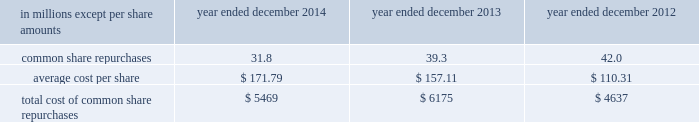Notes to consolidated financial statements guarantees of subsidiaries .
Group inc .
Fully and unconditionally guarantees the securities issued by gs finance corp. , a wholly-owned finance subsidiary of the group inc .
Has guaranteed the payment obligations of goldman , sachs & co .
( gs&co. ) , gs bank usa and goldman sachs execution & clearing , l.p .
( gsec ) , subject to certain exceptions .
In november 2008 , the firm contributed subsidiaries into gs bank usa , and group inc .
Agreed to guarantee the reimbursement of certain losses , including credit-related losses , relating to assets held by the contributed entities .
In connection with this guarantee , group inc .
Also agreed to pledge to gs bank usa certain collateral , including interests in subsidiaries and other illiquid assets .
In addition , group inc .
Guarantees many of the obligations of its other consolidated subsidiaries on a transaction-by- transaction basis , as negotiated with counterparties .
Group inc .
Is unable to develop an estimate of the maximum payout under its subsidiary guarantees ; however , because these guaranteed obligations are also obligations of consolidated subsidiaries , group inc . 2019s liabilities as guarantor are not separately disclosed .
Note 19 .
Shareholders 2019 equity common equity dividends declared per common share were $ 2.25 in 2014 , $ 2.05 in 2013 and $ 1.77 in 2012 .
On january 15 , 2015 , group inc .
Declared a dividend of $ 0.60 per common share to be paid on march 30 , 2015 to common shareholders of record on march 2 , 2015 .
The firm 2019s share repurchase program is intended to help maintain the appropriate level of common equity .
The share repurchase program is effected primarily through regular open-market purchases ( which may include repurchase plans designed to comply with rule 10b5-1 ) , the amounts and timing of which are determined primarily by the firm 2019s current and projected capital position , but which may also be influenced by general market conditions and the prevailing price and trading volumes of the firm 2019s common stock .
Prior to repurchasing common stock , the firm must receive confirmation that the federal reserve board does not object to such capital actions .
The table below presents the amount of common stock repurchased by the firm under the share repurchase program during 2014 , 2013 and 2012. .
Total cost of common share repurchases $ 5469 $ 6175 $ 4637 pursuant to the terms of certain share-based compensation plans , employees may remit shares to the firm or the firm may cancel restricted stock units ( rsus ) or stock options to satisfy minimum statutory employee tax withholding requirements and the exercise price of stock options .
Under these plans , during 2014 , 2013 and 2012 , employees remitted 174489 shares , 161211 shares and 33477 shares with a total value of $ 31 million , $ 25 million and $ 3 million , and the firm cancelled 5.8 million , 4.0 million and 12.7 million of rsus with a total value of $ 974 million , $ 599 million and $ 1.44 billion .
Under these plans , the firm also cancelled 15.6 million stock options with a total value of $ 2.65 billion during 2014 .
170 goldman sachs 2014 annual report .
What were total common equity dividends declared per common share for 2014 and 2013? 
Computations: (2.25 + 2.05)
Answer: 4.3. 